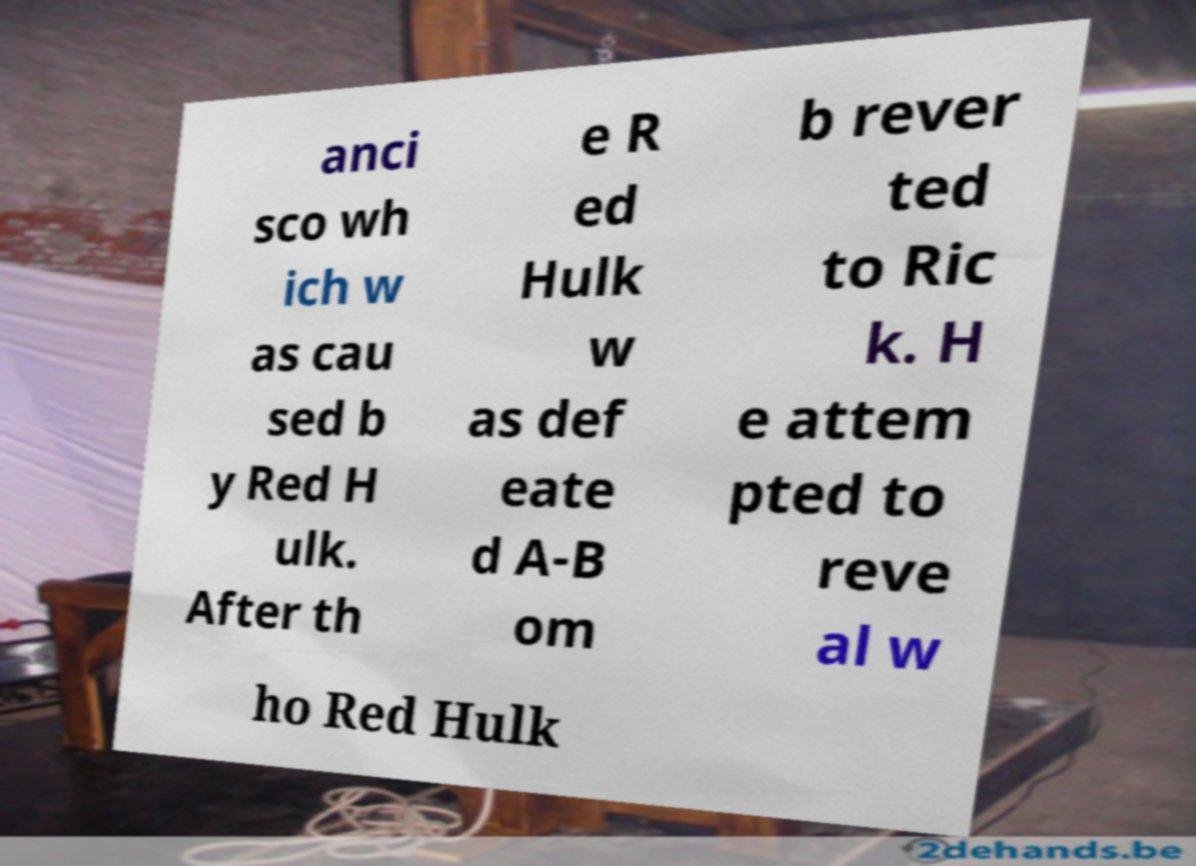Please read and relay the text visible in this image. What does it say? anci sco wh ich w as cau sed b y Red H ulk. After th e R ed Hulk w as def eate d A-B om b rever ted to Ric k. H e attem pted to reve al w ho Red Hulk 